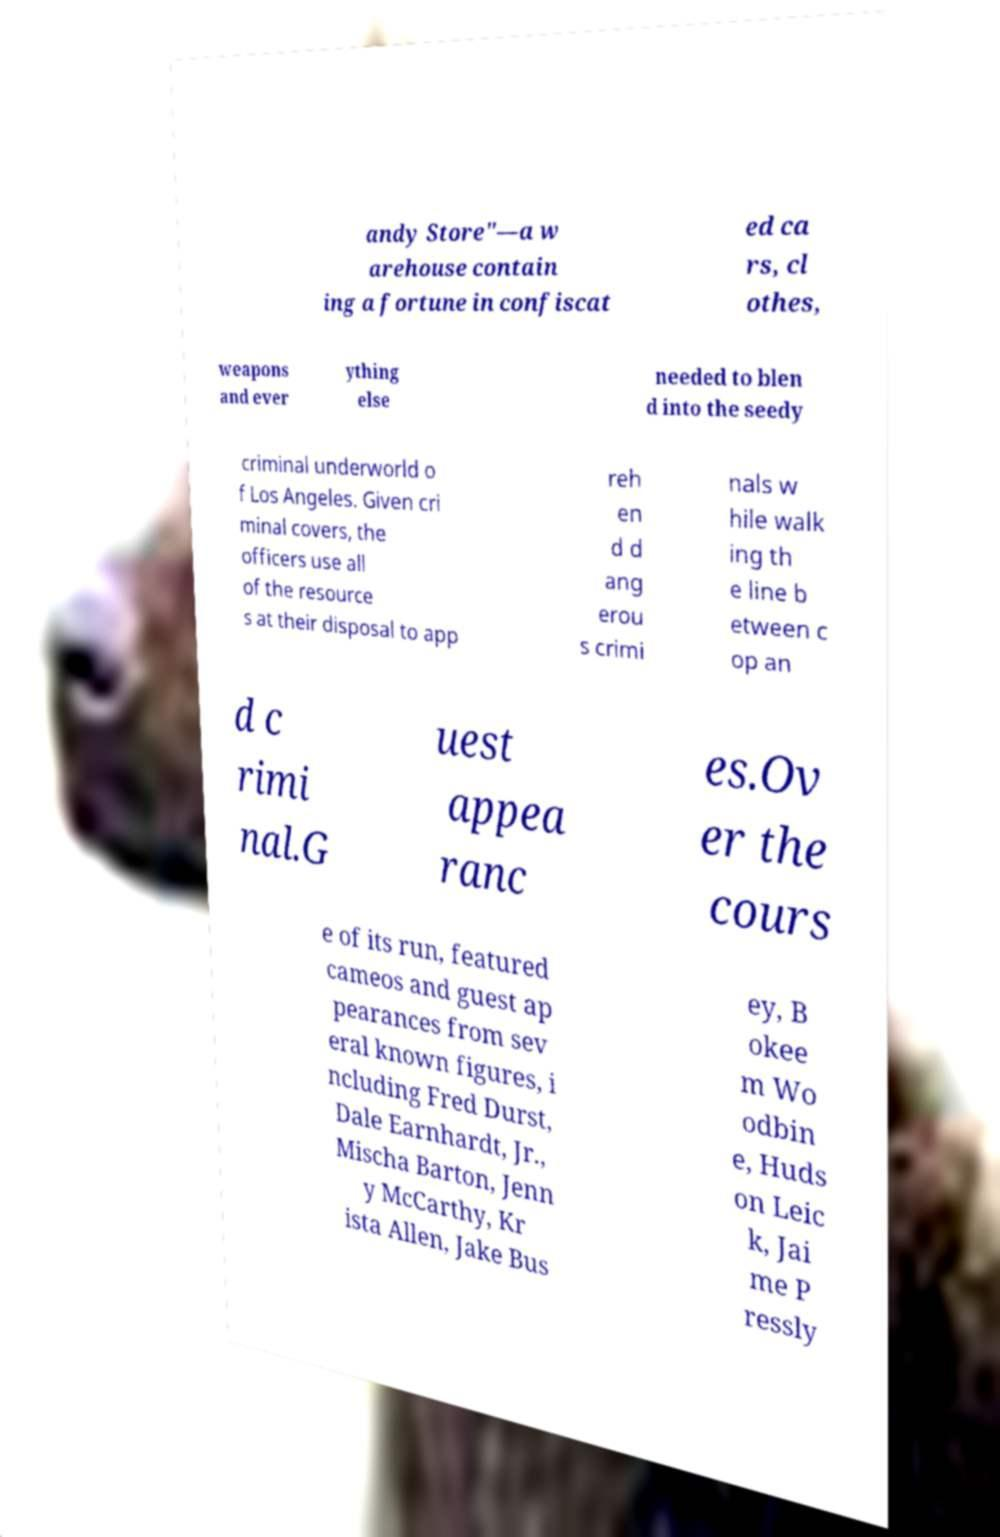For documentation purposes, I need the text within this image transcribed. Could you provide that? andy Store"—a w arehouse contain ing a fortune in confiscat ed ca rs, cl othes, weapons and ever ything else needed to blen d into the seedy criminal underworld o f Los Angeles. Given cri minal covers, the officers use all of the resource s at their disposal to app reh en d d ang erou s crimi nals w hile walk ing th e line b etween c op an d c rimi nal.G uest appea ranc es.Ov er the cours e of its run, featured cameos and guest ap pearances from sev eral known figures, i ncluding Fred Durst, Dale Earnhardt, Jr., Mischa Barton, Jenn y McCarthy, Kr ista Allen, Jake Bus ey, B okee m Wo odbin e, Huds on Leic k, Jai me P ressly 